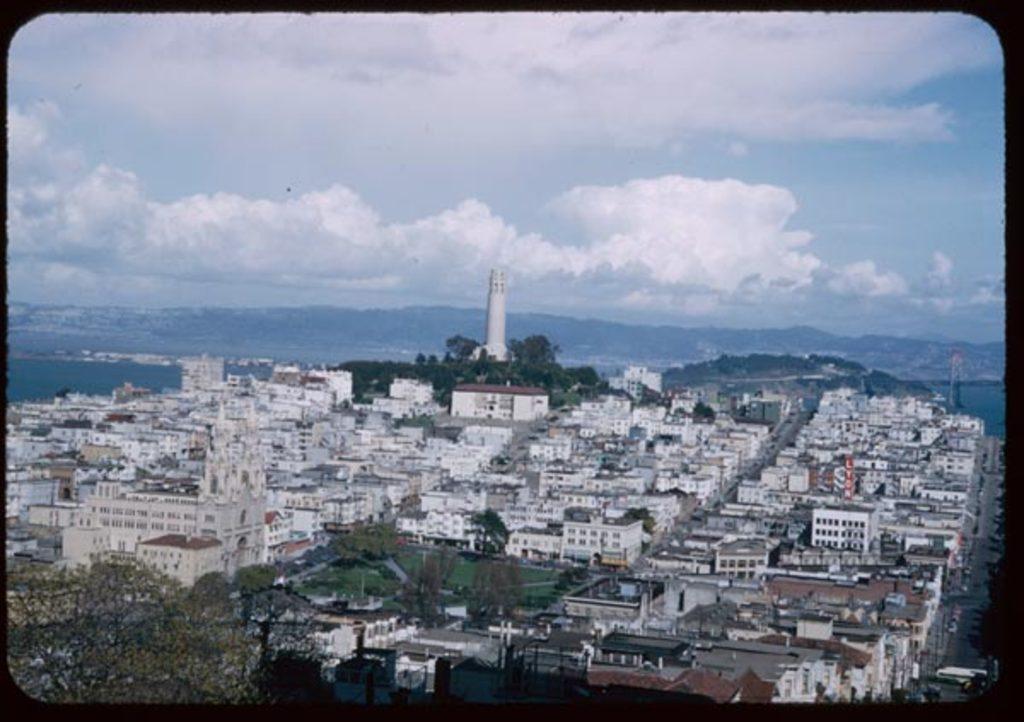How would you summarize this image in a sentence or two? In this image I can see a photo where we can see buildings, trees, tower and mountains. 